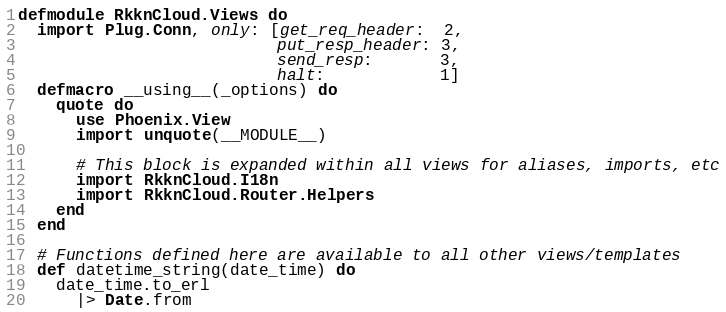Convert code to text. <code><loc_0><loc_0><loc_500><loc_500><_Elixir_>defmodule RkknCloud.Views do
  import Plug.Conn, only: [get_req_header:  2,
                           put_resp_header: 3,
                           send_resp:       3,
                           halt:            1]
  defmacro __using__(_options) do
    quote do
      use Phoenix.View
      import unquote(__MODULE__)

      # This block is expanded within all views for aliases, imports, etc
      import RkknCloud.I18n
      import RkknCloud.Router.Helpers
    end
  end

  # Functions defined here are available to all other views/templates
  def datetime_string(date_time) do
    date_time.to_erl
      |> Date.from</code> 